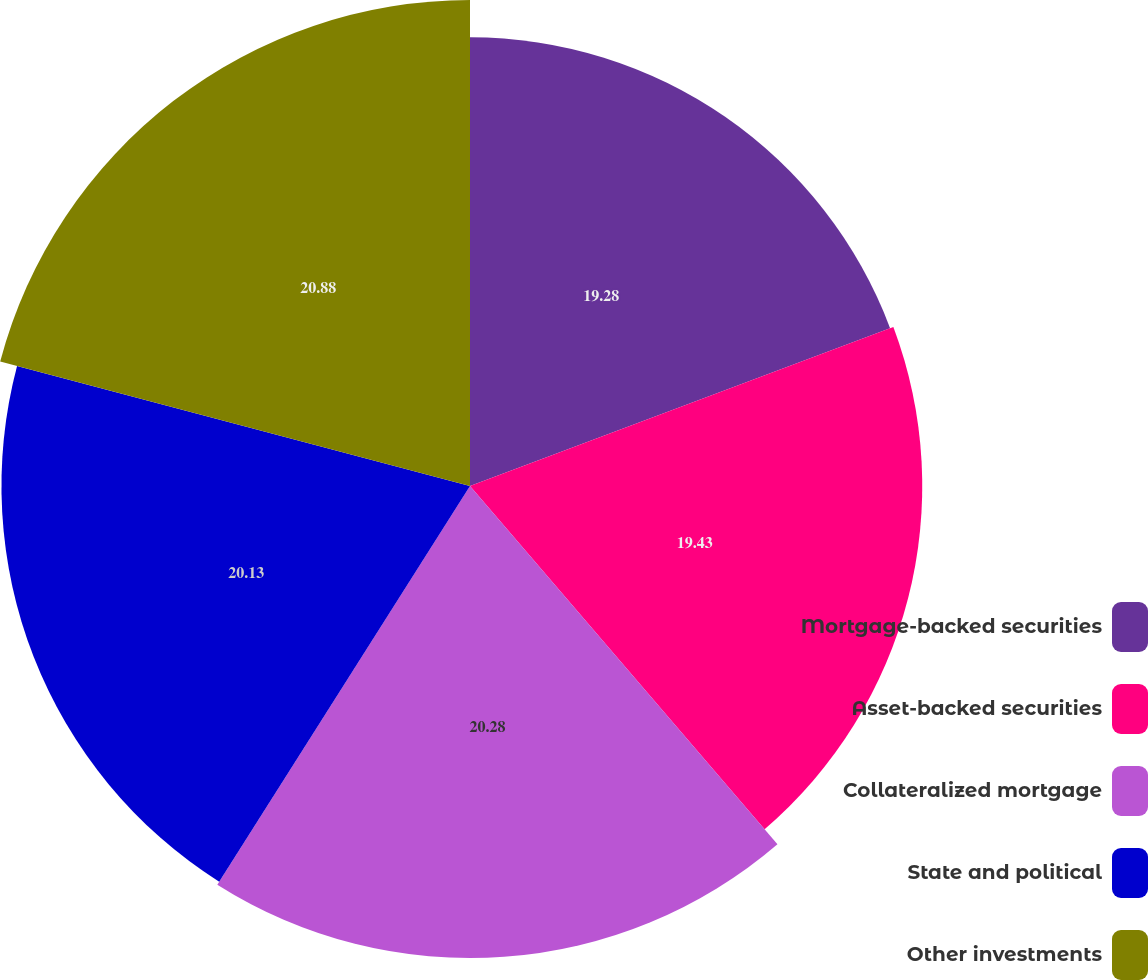<chart> <loc_0><loc_0><loc_500><loc_500><pie_chart><fcel>Mortgage-backed securities<fcel>Asset-backed securities<fcel>Collateralized mortgage<fcel>State and political<fcel>Other investments<nl><fcel>19.28%<fcel>19.43%<fcel>20.28%<fcel>20.13%<fcel>20.88%<nl></chart> 